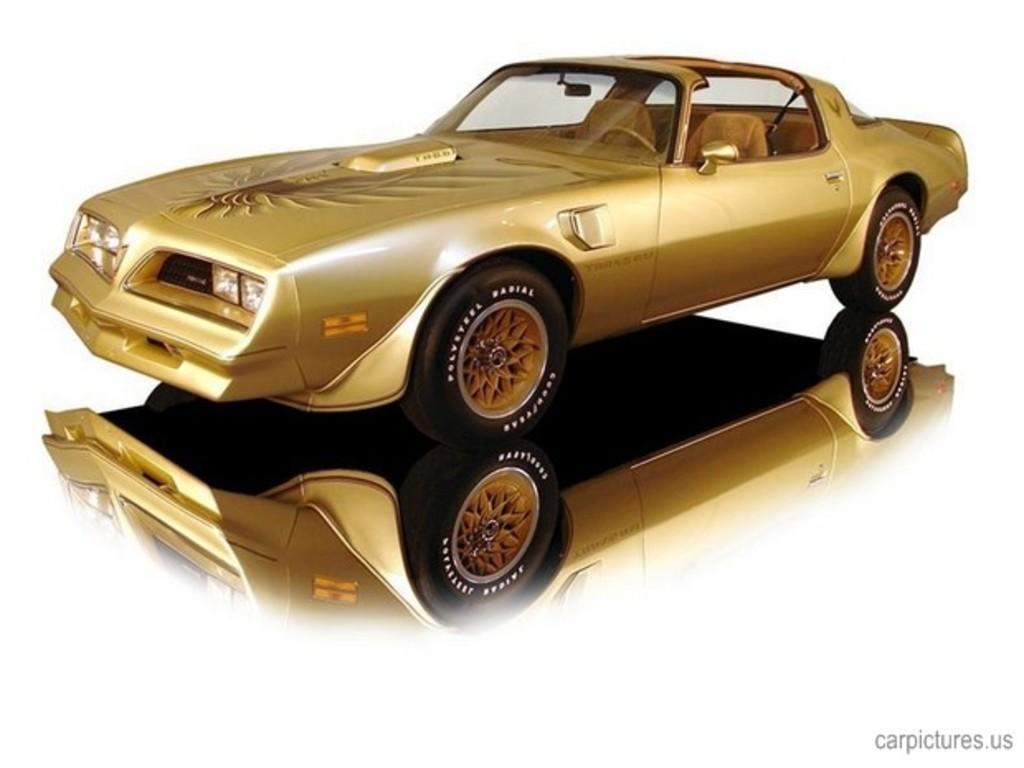Please provide a concise description of this image. In this image we can see a car. There is a reflection of a car on the surface. There is a white background in the image. 